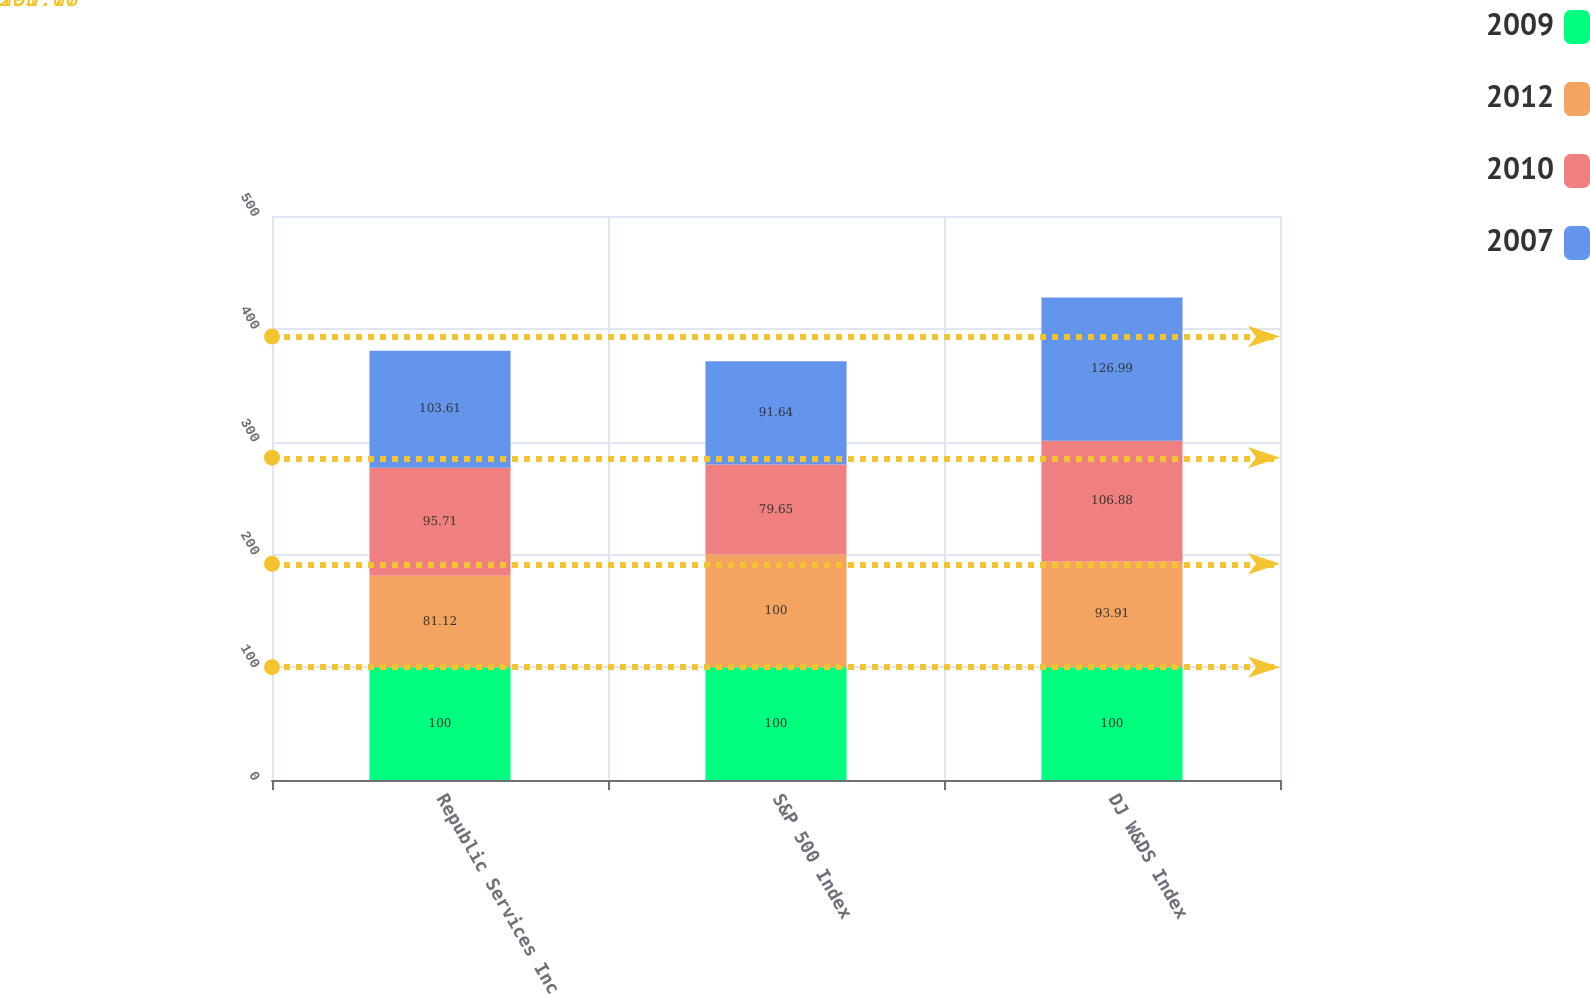Convert chart to OTSL. <chart><loc_0><loc_0><loc_500><loc_500><stacked_bar_chart><ecel><fcel>Republic Services Inc<fcel>S&P 500 Index<fcel>DJ W&DS Index<nl><fcel>2009<fcel>100<fcel>100<fcel>100<nl><fcel>2012<fcel>81.12<fcel>100<fcel>93.91<nl><fcel>2010<fcel>95.71<fcel>79.65<fcel>106.88<nl><fcel>2007<fcel>103.61<fcel>91.64<fcel>126.99<nl></chart> 